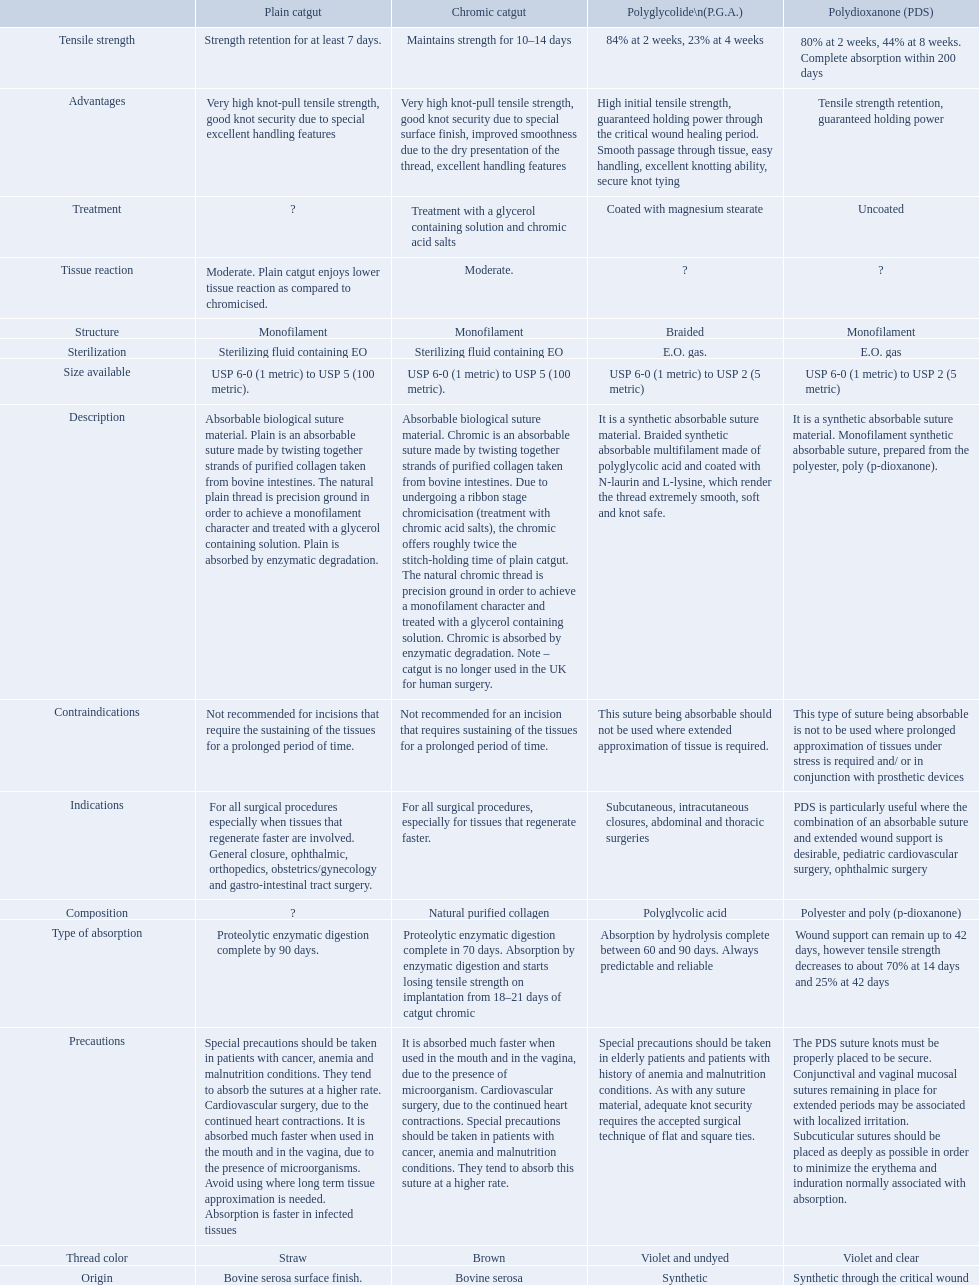Which are the different tensile strengths of the suture materials in the comparison chart? Strength retention for at least 7 days., Maintains strength for 10–14 days, 84% at 2 weeks, 23% at 4 weeks, 80% at 2 weeks, 44% at 8 weeks. Complete absorption within 200 days. Of these, which belongs to plain catgut? Strength retention for at least 7 days. 